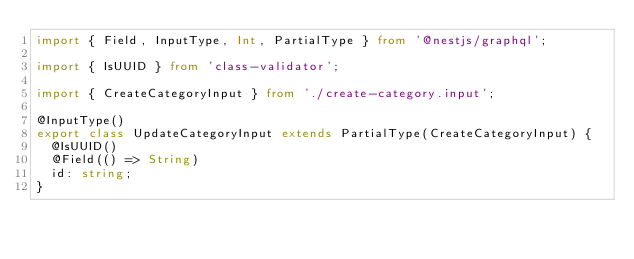<code> <loc_0><loc_0><loc_500><loc_500><_TypeScript_>import { Field, InputType, Int, PartialType } from '@nestjs/graphql';

import { IsUUID } from 'class-validator';

import { CreateCategoryInput } from './create-category.input';

@InputType()
export class UpdateCategoryInput extends PartialType(CreateCategoryInput) {
  @IsUUID()
  @Field(() => String)
  id: string;
}
</code> 